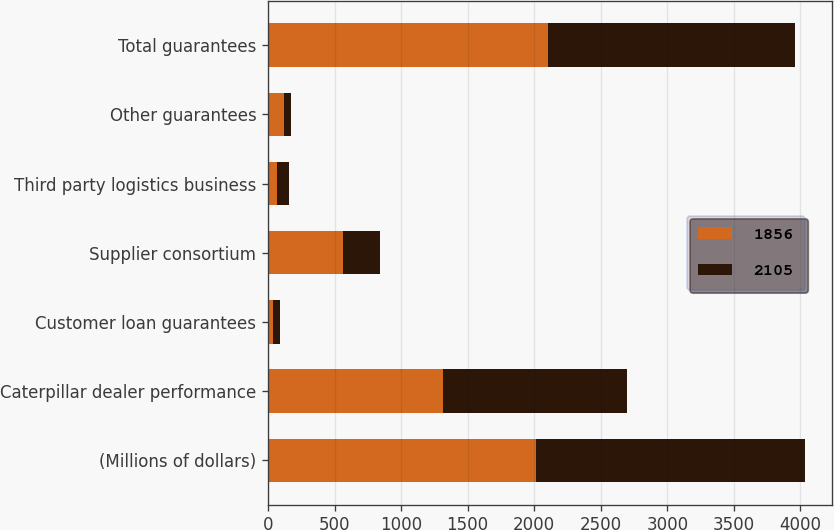<chart> <loc_0><loc_0><loc_500><loc_500><stacked_bar_chart><ecel><fcel>(Millions of dollars)<fcel>Caterpillar dealer performance<fcel>Customer loan guarantees<fcel>Supplier consortium<fcel>Third party logistics business<fcel>Other guarantees<fcel>Total guarantees<nl><fcel>1856<fcel>2017<fcel>1313<fcel>40<fcel>565<fcel>69<fcel>118<fcel>2105<nl><fcel>2105<fcel>2016<fcel>1384<fcel>51<fcel>278<fcel>87<fcel>56<fcel>1856<nl></chart> 